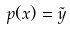<formula> <loc_0><loc_0><loc_500><loc_500>p ( x ) = \tilde { y }</formula> 